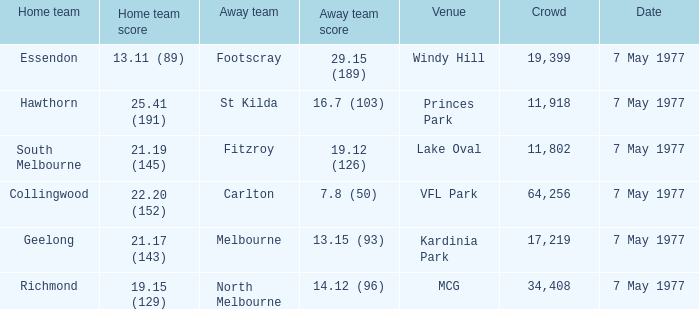Name the venue with a home team of geelong Kardinia Park. 